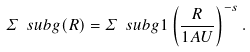<formula> <loc_0><loc_0><loc_500><loc_500>\varSigma \ s u b { g } ( R ) = \varSigma \ s u b { g 1 } \left ( \frac { R } { 1 A U } \right ) ^ { - s } .</formula> 